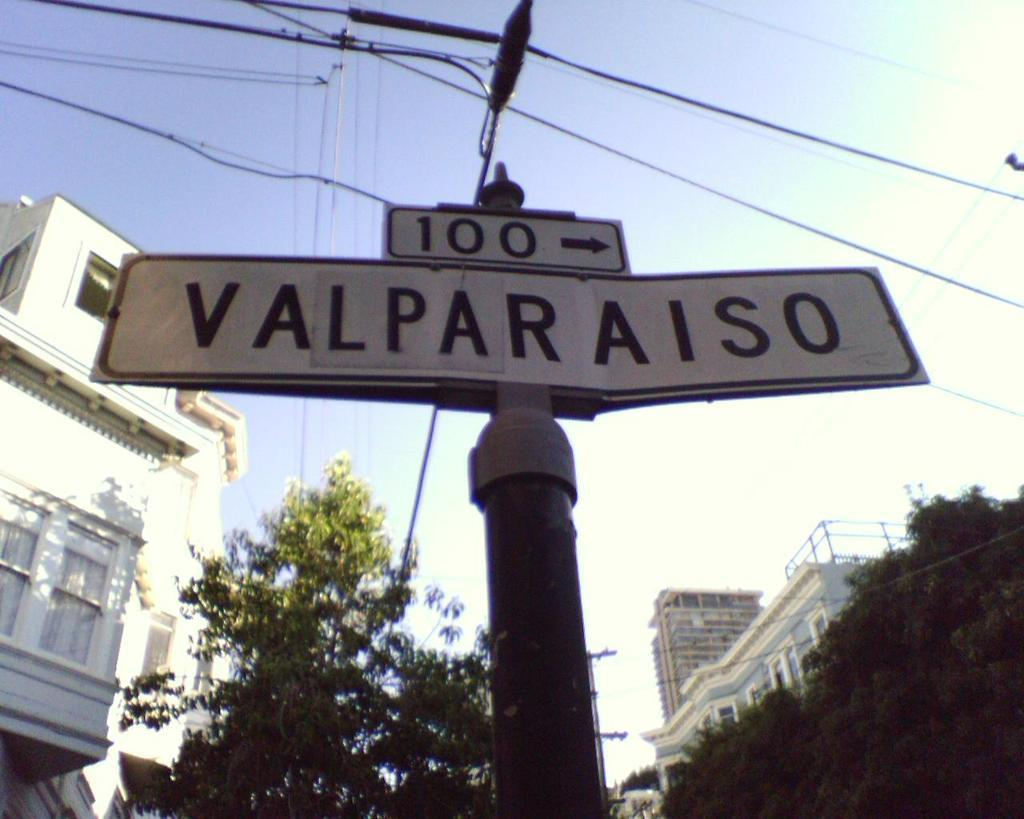What is attached to the pole in the image? There are boards attached to a pole in the image. What else can be seen in the image besides the boards and pole? There are wires, trees, buildings, and the sky visible in the image. Can you describe the type of vegetation in the image? There are trees in the image. What is visible in the background of the image? The sky is visible in the background of the image. Is there any quicksand visible in the image? No, there is no quicksand present in the image. What type of ocean can be seen in the image? There is no ocean visible in the image. 